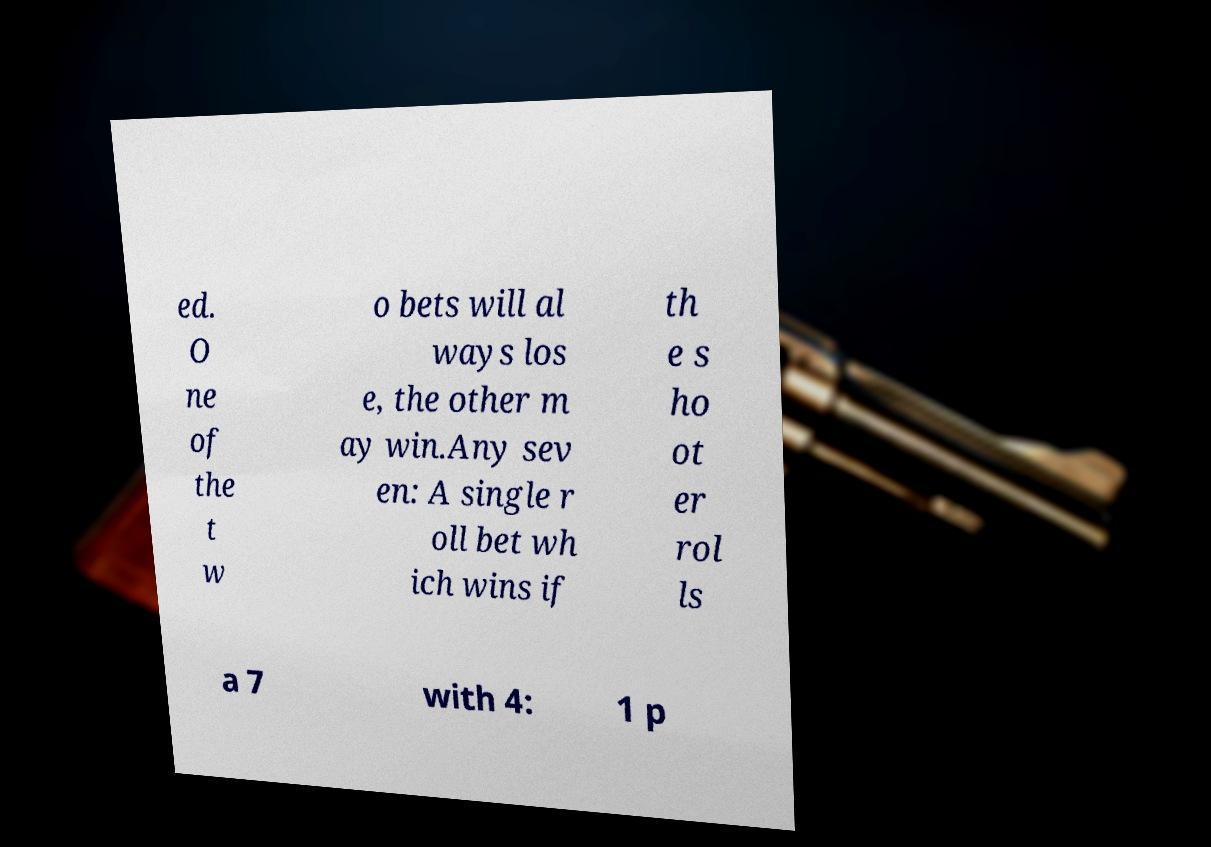There's text embedded in this image that I need extracted. Can you transcribe it verbatim? ed. O ne of the t w o bets will al ways los e, the other m ay win.Any sev en: A single r oll bet wh ich wins if th e s ho ot er rol ls a 7 with 4: 1 p 